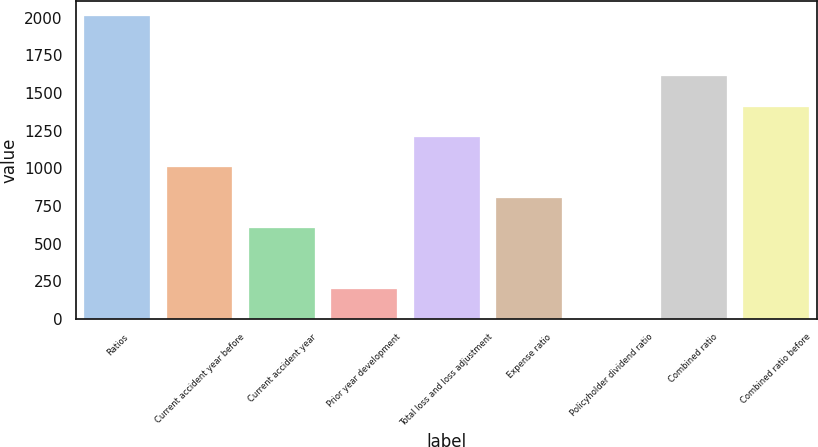<chart> <loc_0><loc_0><loc_500><loc_500><bar_chart><fcel>Ratios<fcel>Current accident year before<fcel>Current accident year<fcel>Prior year development<fcel>Total loss and loss adjustment<fcel>Expense ratio<fcel>Policyholder dividend ratio<fcel>Combined ratio<fcel>Combined ratio before<nl><fcel>2013<fcel>1006.65<fcel>604.11<fcel>201.57<fcel>1207.92<fcel>805.38<fcel>0.3<fcel>1610.46<fcel>1409.19<nl></chart> 